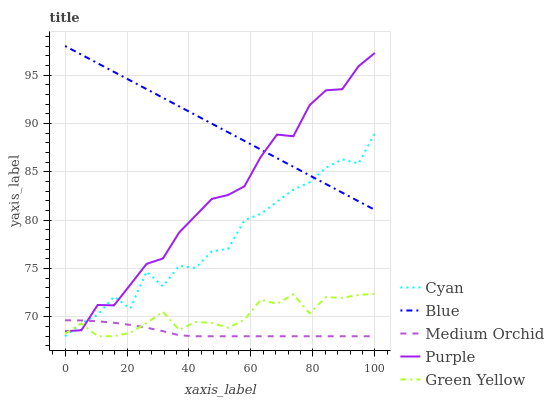Does Medium Orchid have the minimum area under the curve?
Answer yes or no. Yes. Does Blue have the maximum area under the curve?
Answer yes or no. Yes. Does Cyan have the minimum area under the curve?
Answer yes or no. No. Does Cyan have the maximum area under the curve?
Answer yes or no. No. Is Blue the smoothest?
Answer yes or no. Yes. Is Cyan the roughest?
Answer yes or no. Yes. Is Green Yellow the smoothest?
Answer yes or no. No. Is Green Yellow the roughest?
Answer yes or no. No. Does Purple have the lowest value?
Answer yes or no. No. Does Blue have the highest value?
Answer yes or no. Yes. Does Cyan have the highest value?
Answer yes or no. No. Is Medium Orchid less than Blue?
Answer yes or no. Yes. Is Blue greater than Green Yellow?
Answer yes or no. Yes. Does Medium Orchid intersect Blue?
Answer yes or no. No. 